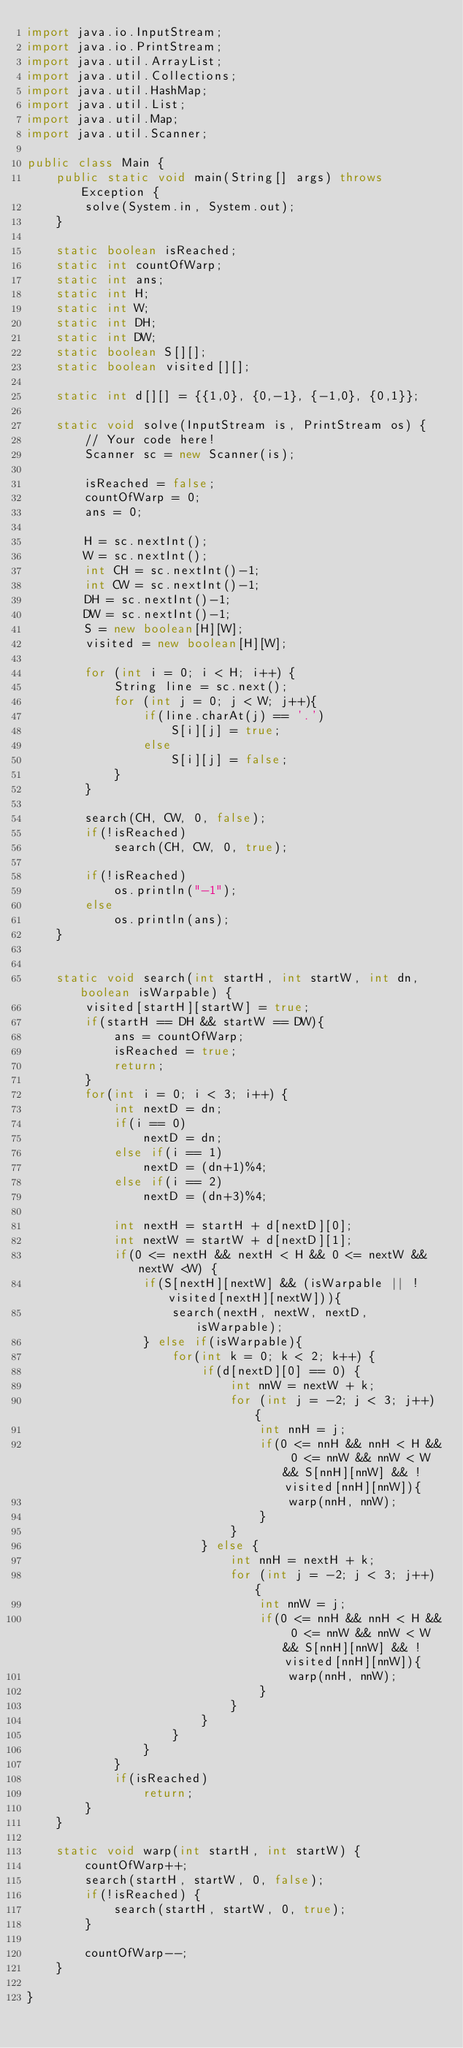Convert code to text. <code><loc_0><loc_0><loc_500><loc_500><_Java_>import java.io.InputStream;
import java.io.PrintStream;
import java.util.ArrayList;
import java.util.Collections;
import java.util.HashMap;
import java.util.List;
import java.util.Map;
import java.util.Scanner;

public class Main {
    public static void main(String[] args) throws Exception {
        solve(System.in, System.out);
    }

    static boolean isReached;
    static int countOfWarp;
    static int ans;
    static int H;
    static int W;
    static int DH;
    static int DW;
    static boolean S[][];
    static boolean visited[][];

    static int d[][] = {{1,0}, {0,-1}, {-1,0}, {0,1}};

    static void solve(InputStream is, PrintStream os) {
        // Your code here!
        Scanner sc = new Scanner(is);

        isReached = false;
        countOfWarp = 0;
        ans = 0;

        H = sc.nextInt();
        W = sc.nextInt();
        int CH = sc.nextInt()-1;
        int CW = sc.nextInt()-1;
        DH = sc.nextInt()-1;
        DW = sc.nextInt()-1;
        S = new boolean[H][W];
        visited = new boolean[H][W];

        for (int i = 0; i < H; i++) {
            String line = sc.next();
            for (int j = 0; j < W; j++){
                if(line.charAt(j) == '.')
                    S[i][j] = true;
                else
                    S[i][j] = false;
            }
        }

        search(CH, CW, 0, false);
        if(!isReached)
            search(CH, CW, 0, true);

        if(!isReached)
            os.println("-1");
        else
            os.println(ans);
    }


    static void search(int startH, int startW, int dn, boolean isWarpable) {
        visited[startH][startW] = true;
        if(startH == DH && startW == DW){
            ans = countOfWarp;
            isReached = true;
            return;
        }
        for(int i = 0; i < 3; i++) {
            int nextD = dn;
            if(i == 0)
                nextD = dn;
            else if(i == 1)
                nextD = (dn+1)%4;
            else if(i == 2)
                nextD = (dn+3)%4;

            int nextH = startH + d[nextD][0];
            int nextW = startW + d[nextD][1];
            if(0 <= nextH && nextH < H && 0 <= nextW && nextW <W) {
                if(S[nextH][nextW] && (isWarpable || !visited[nextH][nextW])){
                    search(nextH, nextW, nextD, isWarpable);
                } else if(isWarpable){
                    for(int k = 0; k < 2; k++) {
                        if(d[nextD][0] == 0) {
                            int nnW = nextW + k;
                            for (int j = -2; j < 3; j++) {
                                int nnH = j;
                                if(0 <= nnH && nnH < H && 0 <= nnW && nnW < W && S[nnH][nnW] && !visited[nnH][nnW]){
                                    warp(nnH, nnW);
                                }
                            }
                        } else {
                            int nnH = nextH + k;
                            for (int j = -2; j < 3; j++) {
                                int nnW = j;
                                if(0 <= nnH && nnH < H && 0 <= nnW && nnW < W && S[nnH][nnW] && !visited[nnH][nnW]){
                                    warp(nnH, nnW);
                                }
                            }
                        }
                    }
                }
            }
            if(isReached)
                return;
        }
    }

    static void warp(int startH, int startW) {
        countOfWarp++;
        search(startH, startW, 0, false);
        if(!isReached) {
            search(startH, startW, 0, true);
        }

        countOfWarp--;
    }

}</code> 